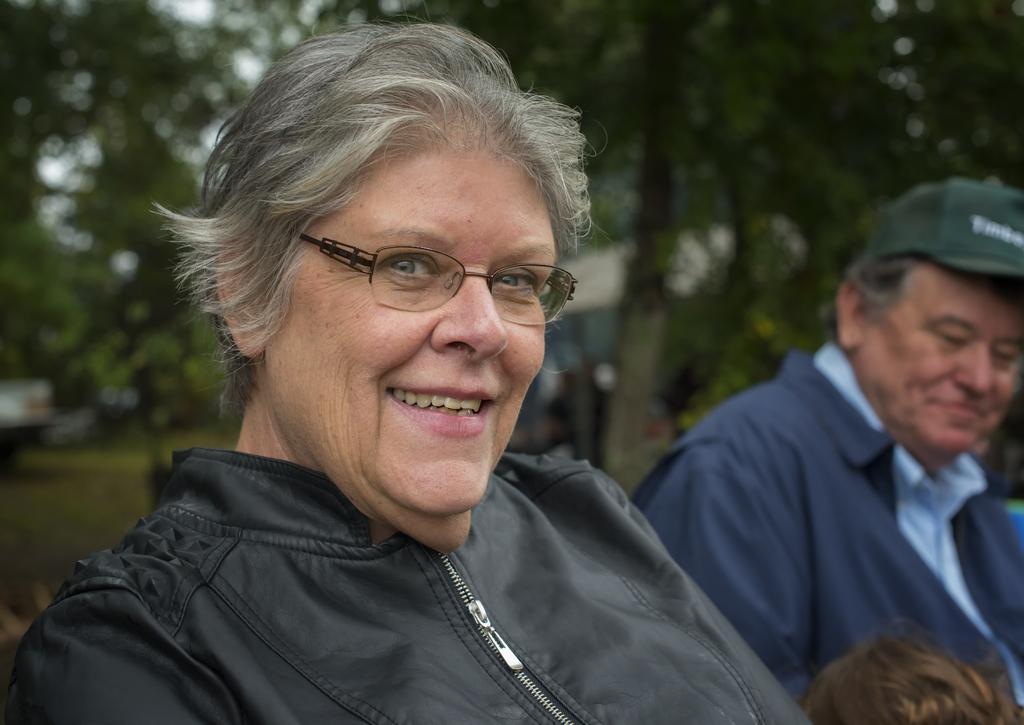Describe this image in one or two sentences. In this image, we can see two people sitting, in the background, there is grass on the ground, we can see some green trees. 